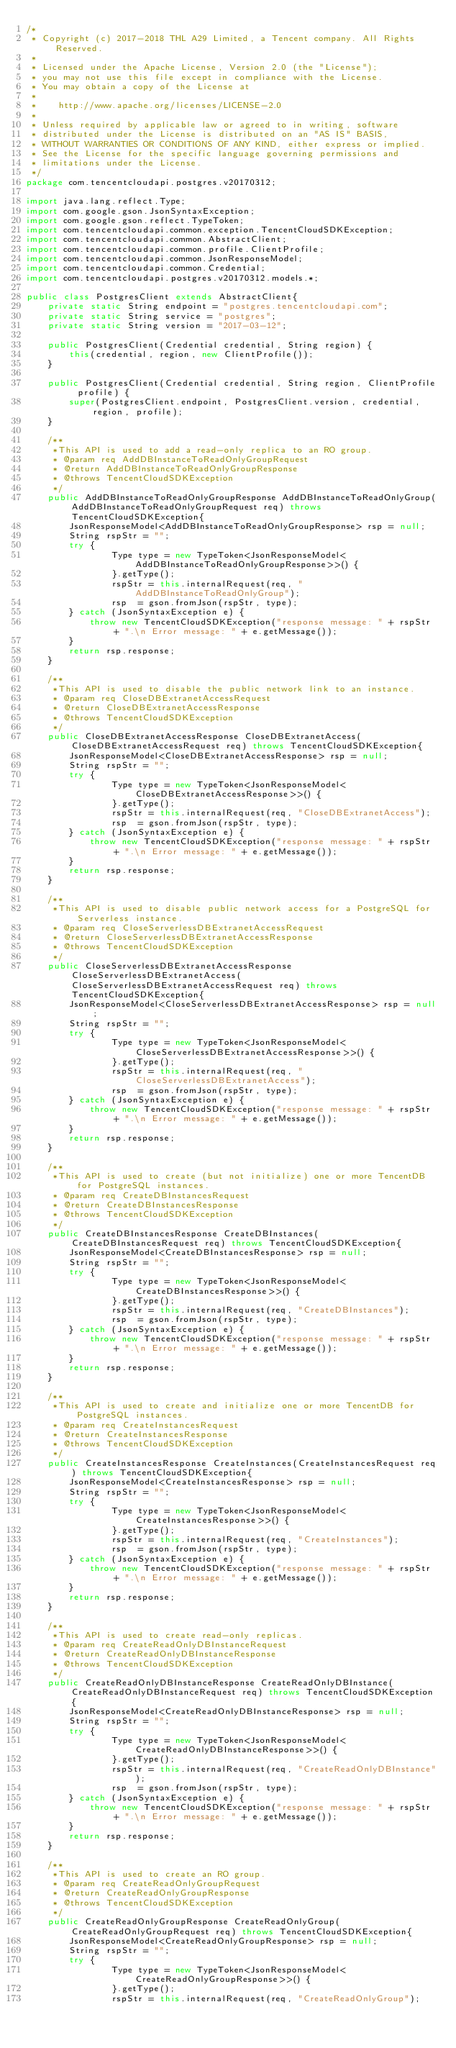<code> <loc_0><loc_0><loc_500><loc_500><_Java_>/*
 * Copyright (c) 2017-2018 THL A29 Limited, a Tencent company. All Rights Reserved.
 *
 * Licensed under the Apache License, Version 2.0 (the "License");
 * you may not use this file except in compliance with the License.
 * You may obtain a copy of the License at
 *
 *    http://www.apache.org/licenses/LICENSE-2.0
 *
 * Unless required by applicable law or agreed to in writing, software
 * distributed under the License is distributed on an "AS IS" BASIS,
 * WITHOUT WARRANTIES OR CONDITIONS OF ANY KIND, either express or implied.
 * See the License for the specific language governing permissions and
 * limitations under the License.
 */
package com.tencentcloudapi.postgres.v20170312;

import java.lang.reflect.Type;
import com.google.gson.JsonSyntaxException;
import com.google.gson.reflect.TypeToken;
import com.tencentcloudapi.common.exception.TencentCloudSDKException;
import com.tencentcloudapi.common.AbstractClient;
import com.tencentcloudapi.common.profile.ClientProfile;
import com.tencentcloudapi.common.JsonResponseModel;
import com.tencentcloudapi.common.Credential;
import com.tencentcloudapi.postgres.v20170312.models.*;

public class PostgresClient extends AbstractClient{
    private static String endpoint = "postgres.tencentcloudapi.com";
    private static String service = "postgres";
    private static String version = "2017-03-12";

    public PostgresClient(Credential credential, String region) {
        this(credential, region, new ClientProfile());
    }

    public PostgresClient(Credential credential, String region, ClientProfile profile) {
        super(PostgresClient.endpoint, PostgresClient.version, credential, region, profile);
    }

    /**
     *This API is used to add a read-only replica to an RO group.
     * @param req AddDBInstanceToReadOnlyGroupRequest
     * @return AddDBInstanceToReadOnlyGroupResponse
     * @throws TencentCloudSDKException
     */
    public AddDBInstanceToReadOnlyGroupResponse AddDBInstanceToReadOnlyGroup(AddDBInstanceToReadOnlyGroupRequest req) throws TencentCloudSDKException{
        JsonResponseModel<AddDBInstanceToReadOnlyGroupResponse> rsp = null;
        String rspStr = "";
        try {
                Type type = new TypeToken<JsonResponseModel<AddDBInstanceToReadOnlyGroupResponse>>() {
                }.getType();
                rspStr = this.internalRequest(req, "AddDBInstanceToReadOnlyGroup");
                rsp  = gson.fromJson(rspStr, type);
        } catch (JsonSyntaxException e) {
            throw new TencentCloudSDKException("response message: " + rspStr + ".\n Error message: " + e.getMessage());
        }
        return rsp.response;
    }

    /**
     *This API is used to disable the public network link to an instance.
     * @param req CloseDBExtranetAccessRequest
     * @return CloseDBExtranetAccessResponse
     * @throws TencentCloudSDKException
     */
    public CloseDBExtranetAccessResponse CloseDBExtranetAccess(CloseDBExtranetAccessRequest req) throws TencentCloudSDKException{
        JsonResponseModel<CloseDBExtranetAccessResponse> rsp = null;
        String rspStr = "";
        try {
                Type type = new TypeToken<JsonResponseModel<CloseDBExtranetAccessResponse>>() {
                }.getType();
                rspStr = this.internalRequest(req, "CloseDBExtranetAccess");
                rsp  = gson.fromJson(rspStr, type);
        } catch (JsonSyntaxException e) {
            throw new TencentCloudSDKException("response message: " + rspStr + ".\n Error message: " + e.getMessage());
        }
        return rsp.response;
    }

    /**
     *This API is used to disable public network access for a PostgreSQL for Serverless instance.
     * @param req CloseServerlessDBExtranetAccessRequest
     * @return CloseServerlessDBExtranetAccessResponse
     * @throws TencentCloudSDKException
     */
    public CloseServerlessDBExtranetAccessResponse CloseServerlessDBExtranetAccess(CloseServerlessDBExtranetAccessRequest req) throws TencentCloudSDKException{
        JsonResponseModel<CloseServerlessDBExtranetAccessResponse> rsp = null;
        String rspStr = "";
        try {
                Type type = new TypeToken<JsonResponseModel<CloseServerlessDBExtranetAccessResponse>>() {
                }.getType();
                rspStr = this.internalRequest(req, "CloseServerlessDBExtranetAccess");
                rsp  = gson.fromJson(rspStr, type);
        } catch (JsonSyntaxException e) {
            throw new TencentCloudSDKException("response message: " + rspStr + ".\n Error message: " + e.getMessage());
        }
        return rsp.response;
    }

    /**
     *This API is used to create (but not initialize) one or more TencentDB for PostgreSQL instances.
     * @param req CreateDBInstancesRequest
     * @return CreateDBInstancesResponse
     * @throws TencentCloudSDKException
     */
    public CreateDBInstancesResponse CreateDBInstances(CreateDBInstancesRequest req) throws TencentCloudSDKException{
        JsonResponseModel<CreateDBInstancesResponse> rsp = null;
        String rspStr = "";
        try {
                Type type = new TypeToken<JsonResponseModel<CreateDBInstancesResponse>>() {
                }.getType();
                rspStr = this.internalRequest(req, "CreateDBInstances");
                rsp  = gson.fromJson(rspStr, type);
        } catch (JsonSyntaxException e) {
            throw new TencentCloudSDKException("response message: " + rspStr + ".\n Error message: " + e.getMessage());
        }
        return rsp.response;
    }

    /**
     *This API is used to create and initialize one or more TencentDB for PostgreSQL instances.
     * @param req CreateInstancesRequest
     * @return CreateInstancesResponse
     * @throws TencentCloudSDKException
     */
    public CreateInstancesResponse CreateInstances(CreateInstancesRequest req) throws TencentCloudSDKException{
        JsonResponseModel<CreateInstancesResponse> rsp = null;
        String rspStr = "";
        try {
                Type type = new TypeToken<JsonResponseModel<CreateInstancesResponse>>() {
                }.getType();
                rspStr = this.internalRequest(req, "CreateInstances");
                rsp  = gson.fromJson(rspStr, type);
        } catch (JsonSyntaxException e) {
            throw new TencentCloudSDKException("response message: " + rspStr + ".\n Error message: " + e.getMessage());
        }
        return rsp.response;
    }

    /**
     *This API is used to create read-only replicas.
     * @param req CreateReadOnlyDBInstanceRequest
     * @return CreateReadOnlyDBInstanceResponse
     * @throws TencentCloudSDKException
     */
    public CreateReadOnlyDBInstanceResponse CreateReadOnlyDBInstance(CreateReadOnlyDBInstanceRequest req) throws TencentCloudSDKException{
        JsonResponseModel<CreateReadOnlyDBInstanceResponse> rsp = null;
        String rspStr = "";
        try {
                Type type = new TypeToken<JsonResponseModel<CreateReadOnlyDBInstanceResponse>>() {
                }.getType();
                rspStr = this.internalRequest(req, "CreateReadOnlyDBInstance");
                rsp  = gson.fromJson(rspStr, type);
        } catch (JsonSyntaxException e) {
            throw new TencentCloudSDKException("response message: " + rspStr + ".\n Error message: " + e.getMessage());
        }
        return rsp.response;
    }

    /**
     *This API is used to create an RO group.
     * @param req CreateReadOnlyGroupRequest
     * @return CreateReadOnlyGroupResponse
     * @throws TencentCloudSDKException
     */
    public CreateReadOnlyGroupResponse CreateReadOnlyGroup(CreateReadOnlyGroupRequest req) throws TencentCloudSDKException{
        JsonResponseModel<CreateReadOnlyGroupResponse> rsp = null;
        String rspStr = "";
        try {
                Type type = new TypeToken<JsonResponseModel<CreateReadOnlyGroupResponse>>() {
                }.getType();
                rspStr = this.internalRequest(req, "CreateReadOnlyGroup");</code> 